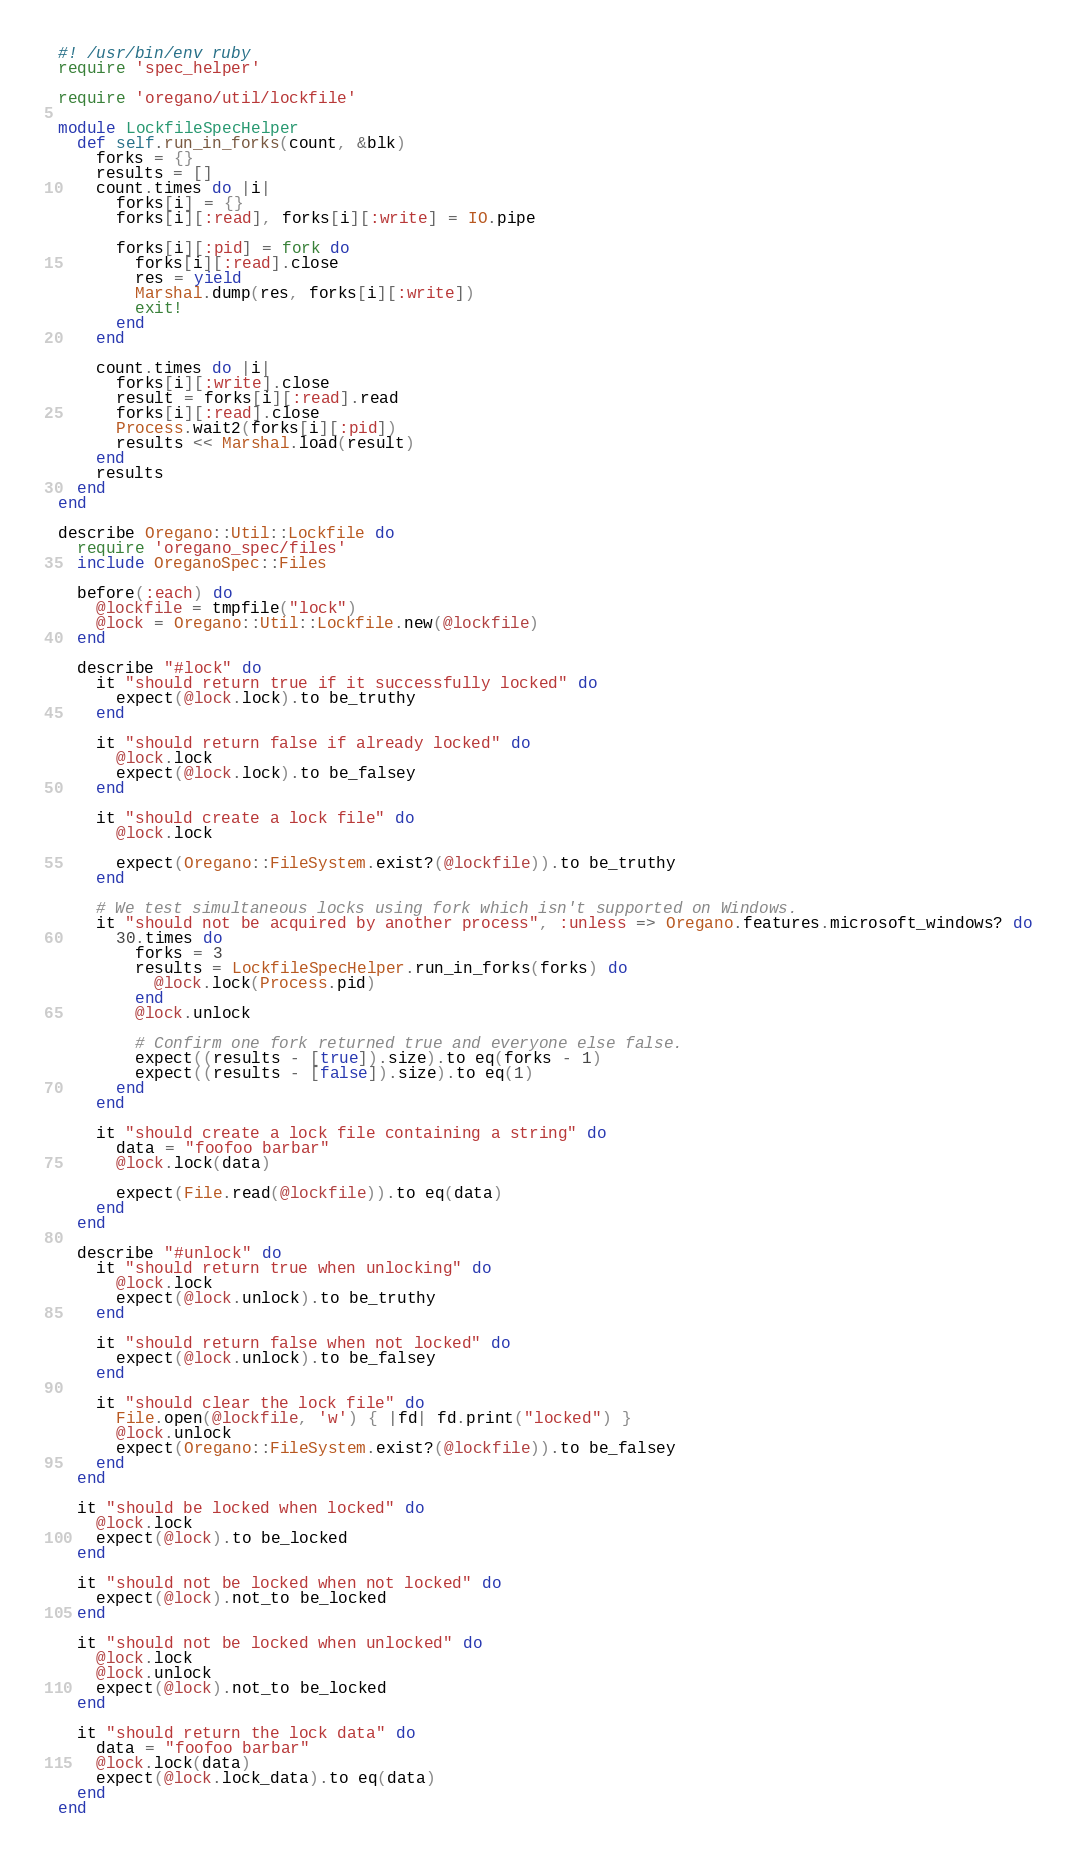<code> <loc_0><loc_0><loc_500><loc_500><_Ruby_>#! /usr/bin/env ruby
require 'spec_helper'

require 'oregano/util/lockfile'

module LockfileSpecHelper
  def self.run_in_forks(count, &blk)
    forks = {}
    results = []
    count.times do |i|
      forks[i] = {}
      forks[i][:read], forks[i][:write] = IO.pipe

      forks[i][:pid] = fork do
        forks[i][:read].close
        res = yield
        Marshal.dump(res, forks[i][:write])
        exit!
      end
    end

    count.times do |i|
      forks[i][:write].close
      result = forks[i][:read].read
      forks[i][:read].close
      Process.wait2(forks[i][:pid])
      results << Marshal.load(result)
    end
    results
  end
end

describe Oregano::Util::Lockfile do
  require 'oregano_spec/files'
  include OreganoSpec::Files

  before(:each) do
    @lockfile = tmpfile("lock")
    @lock = Oregano::Util::Lockfile.new(@lockfile)
  end

  describe "#lock" do
    it "should return true if it successfully locked" do
      expect(@lock.lock).to be_truthy
    end

    it "should return false if already locked" do
      @lock.lock
      expect(@lock.lock).to be_falsey
    end

    it "should create a lock file" do
      @lock.lock

      expect(Oregano::FileSystem.exist?(@lockfile)).to be_truthy
    end

    # We test simultaneous locks using fork which isn't supported on Windows.
    it "should not be acquired by another process", :unless => Oregano.features.microsoft_windows? do
      30.times do
        forks = 3
        results = LockfileSpecHelper.run_in_forks(forks) do
          @lock.lock(Process.pid)
        end
        @lock.unlock

        # Confirm one fork returned true and everyone else false.
        expect((results - [true]).size).to eq(forks - 1)
        expect((results - [false]).size).to eq(1)
      end
    end

    it "should create a lock file containing a string" do
      data = "foofoo barbar"
      @lock.lock(data)

      expect(File.read(@lockfile)).to eq(data)
    end
  end

  describe "#unlock" do
    it "should return true when unlocking" do
      @lock.lock
      expect(@lock.unlock).to be_truthy
    end

    it "should return false when not locked" do
      expect(@lock.unlock).to be_falsey
    end

    it "should clear the lock file" do
      File.open(@lockfile, 'w') { |fd| fd.print("locked") }
      @lock.unlock
      expect(Oregano::FileSystem.exist?(@lockfile)).to be_falsey
    end
  end

  it "should be locked when locked" do
    @lock.lock
    expect(@lock).to be_locked
  end

  it "should not be locked when not locked" do
    expect(@lock).not_to be_locked
  end

  it "should not be locked when unlocked" do
    @lock.lock
    @lock.unlock
    expect(@lock).not_to be_locked
  end

  it "should return the lock data" do
    data = "foofoo barbar"
    @lock.lock(data)
    expect(@lock.lock_data).to eq(data)
  end
end
</code> 